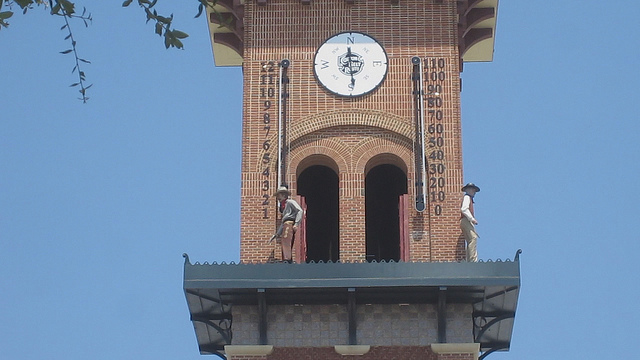What is the device shown in the image?
A. painting
B. clock
C. photography
D. compass
Answer with the option's letter from the given choices directly. D 